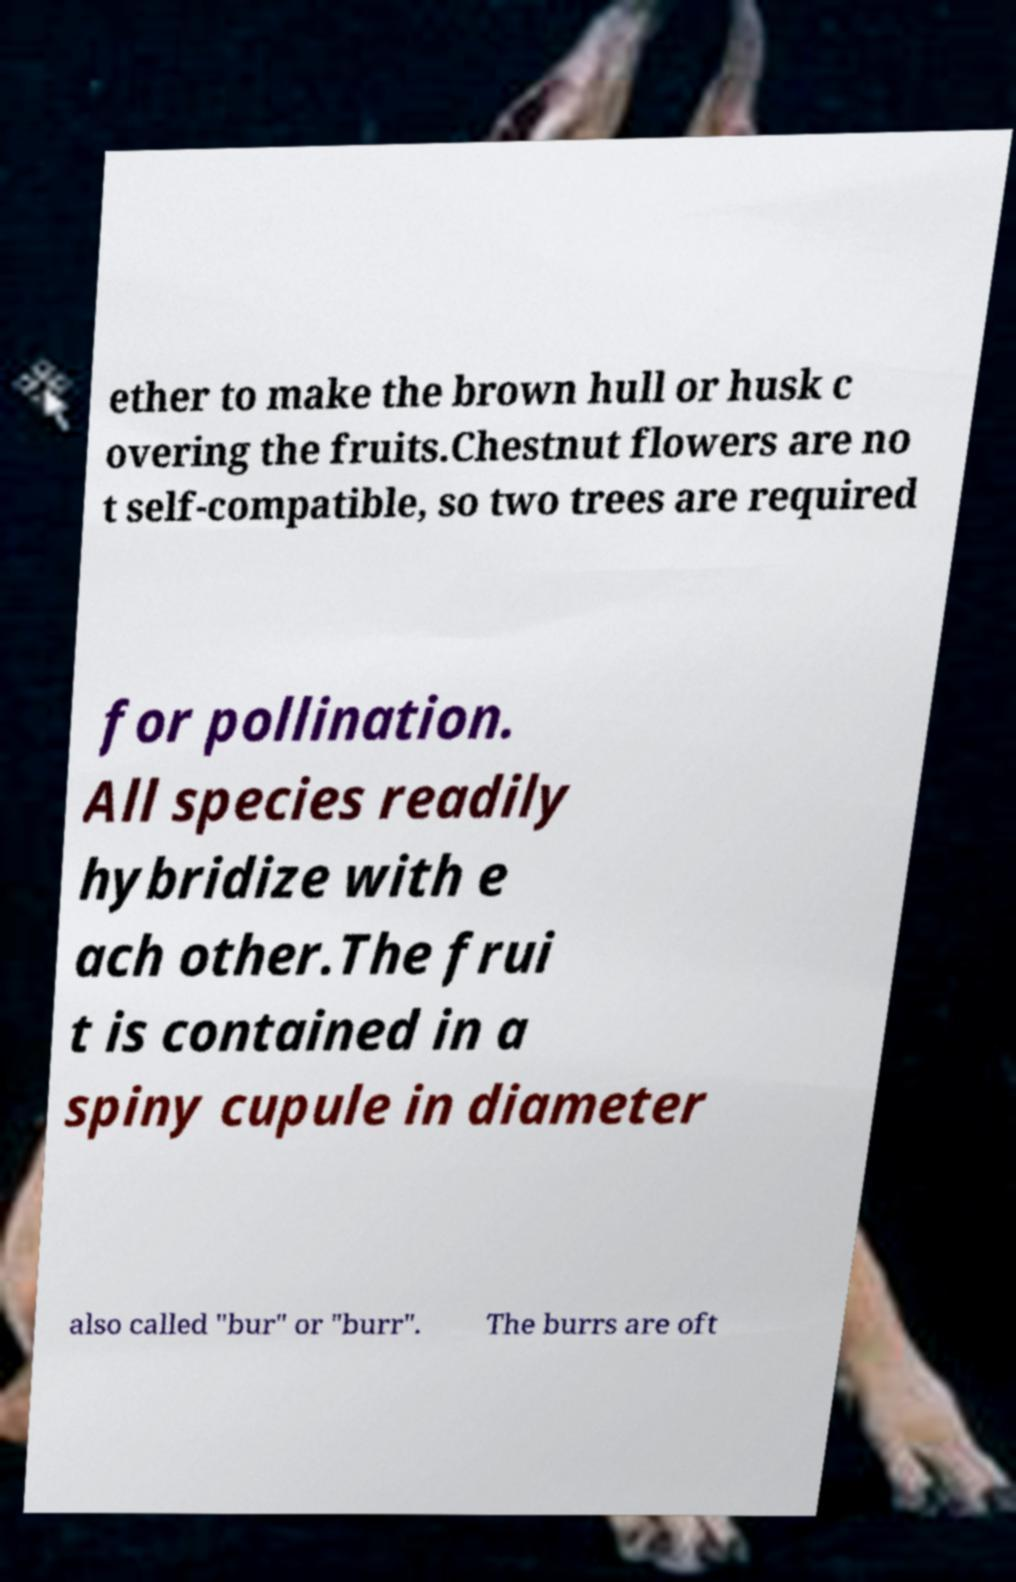I need the written content from this picture converted into text. Can you do that? ether to make the brown hull or husk c overing the fruits.Chestnut flowers are no t self-compatible, so two trees are required for pollination. All species readily hybridize with e ach other.The frui t is contained in a spiny cupule in diameter also called "bur" or "burr". The burrs are oft 